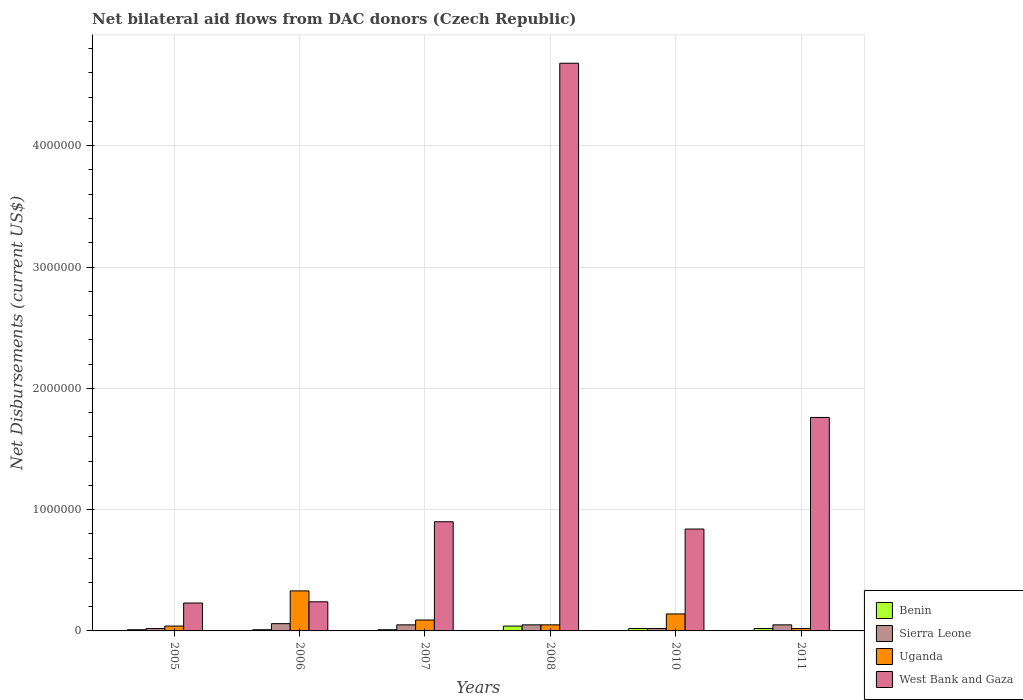How many groups of bars are there?
Keep it short and to the point. 6. Are the number of bars per tick equal to the number of legend labels?
Offer a very short reply. Yes. How many bars are there on the 4th tick from the left?
Offer a terse response. 4. How many bars are there on the 3rd tick from the right?
Your answer should be very brief. 4. What is the label of the 5th group of bars from the left?
Make the answer very short. 2010. In how many cases, is the number of bars for a given year not equal to the number of legend labels?
Ensure brevity in your answer.  0. What is the net bilateral aid flows in Uganda in 2007?
Your answer should be compact. 9.00e+04. Across all years, what is the maximum net bilateral aid flows in Sierra Leone?
Ensure brevity in your answer.  6.00e+04. Across all years, what is the minimum net bilateral aid flows in Uganda?
Your response must be concise. 2.00e+04. In which year was the net bilateral aid flows in Uganda minimum?
Provide a succinct answer. 2011. What is the total net bilateral aid flows in West Bank and Gaza in the graph?
Your answer should be very brief. 8.65e+06. What is the difference between the net bilateral aid flows in Uganda in 2005 and that in 2007?
Your answer should be compact. -5.00e+04. What is the difference between the net bilateral aid flows in West Bank and Gaza in 2007 and the net bilateral aid flows in Benin in 2006?
Provide a short and direct response. 8.90e+05. What is the average net bilateral aid flows in Sierra Leone per year?
Your response must be concise. 4.17e+04. In how many years, is the net bilateral aid flows in Uganda greater than 3800000 US$?
Offer a very short reply. 0. What is the ratio of the net bilateral aid flows in Sierra Leone in 2008 to that in 2011?
Your answer should be compact. 1. Is the net bilateral aid flows in Sierra Leone in 2008 less than that in 2010?
Ensure brevity in your answer.  No. Is the difference between the net bilateral aid flows in Sierra Leone in 2005 and 2010 greater than the difference between the net bilateral aid flows in Uganda in 2005 and 2010?
Offer a very short reply. Yes. What is the difference between the highest and the lowest net bilateral aid flows in West Bank and Gaza?
Provide a succinct answer. 4.45e+06. What does the 4th bar from the left in 2005 represents?
Give a very brief answer. West Bank and Gaza. What does the 3rd bar from the right in 2005 represents?
Make the answer very short. Sierra Leone. How many bars are there?
Keep it short and to the point. 24. Are all the bars in the graph horizontal?
Offer a terse response. No. How many years are there in the graph?
Your answer should be compact. 6. What is the difference between two consecutive major ticks on the Y-axis?
Your response must be concise. 1.00e+06. Are the values on the major ticks of Y-axis written in scientific E-notation?
Your answer should be compact. No. Where does the legend appear in the graph?
Offer a terse response. Bottom right. How many legend labels are there?
Your answer should be very brief. 4. How are the legend labels stacked?
Your response must be concise. Vertical. What is the title of the graph?
Offer a very short reply. Net bilateral aid flows from DAC donors (Czech Republic). What is the label or title of the X-axis?
Provide a short and direct response. Years. What is the label or title of the Y-axis?
Provide a short and direct response. Net Disbursements (current US$). What is the Net Disbursements (current US$) in Sierra Leone in 2005?
Your answer should be very brief. 2.00e+04. What is the Net Disbursements (current US$) in Benin in 2006?
Offer a very short reply. 10000. What is the Net Disbursements (current US$) in Sierra Leone in 2006?
Provide a short and direct response. 6.00e+04. What is the Net Disbursements (current US$) in West Bank and Gaza in 2006?
Your answer should be very brief. 2.40e+05. What is the Net Disbursements (current US$) of Benin in 2007?
Offer a very short reply. 10000. What is the Net Disbursements (current US$) in Sierra Leone in 2007?
Your answer should be very brief. 5.00e+04. What is the Net Disbursements (current US$) of Uganda in 2007?
Ensure brevity in your answer.  9.00e+04. What is the Net Disbursements (current US$) in Sierra Leone in 2008?
Ensure brevity in your answer.  5.00e+04. What is the Net Disbursements (current US$) in West Bank and Gaza in 2008?
Offer a terse response. 4.68e+06. What is the Net Disbursements (current US$) of Sierra Leone in 2010?
Give a very brief answer. 2.00e+04. What is the Net Disbursements (current US$) in Uganda in 2010?
Offer a very short reply. 1.40e+05. What is the Net Disbursements (current US$) in West Bank and Gaza in 2010?
Your response must be concise. 8.40e+05. What is the Net Disbursements (current US$) in West Bank and Gaza in 2011?
Provide a succinct answer. 1.76e+06. Across all years, what is the maximum Net Disbursements (current US$) in West Bank and Gaza?
Your answer should be very brief. 4.68e+06. Across all years, what is the minimum Net Disbursements (current US$) in Benin?
Offer a very short reply. 10000. Across all years, what is the minimum Net Disbursements (current US$) in Sierra Leone?
Provide a succinct answer. 2.00e+04. Across all years, what is the minimum Net Disbursements (current US$) of West Bank and Gaza?
Offer a terse response. 2.30e+05. What is the total Net Disbursements (current US$) in Sierra Leone in the graph?
Offer a terse response. 2.50e+05. What is the total Net Disbursements (current US$) in Uganda in the graph?
Offer a very short reply. 6.70e+05. What is the total Net Disbursements (current US$) of West Bank and Gaza in the graph?
Provide a succinct answer. 8.65e+06. What is the difference between the Net Disbursements (current US$) in West Bank and Gaza in 2005 and that in 2007?
Keep it short and to the point. -6.70e+05. What is the difference between the Net Disbursements (current US$) of Sierra Leone in 2005 and that in 2008?
Provide a short and direct response. -3.00e+04. What is the difference between the Net Disbursements (current US$) of Uganda in 2005 and that in 2008?
Your response must be concise. -10000. What is the difference between the Net Disbursements (current US$) in West Bank and Gaza in 2005 and that in 2008?
Your answer should be very brief. -4.45e+06. What is the difference between the Net Disbursements (current US$) of Sierra Leone in 2005 and that in 2010?
Your answer should be compact. 0. What is the difference between the Net Disbursements (current US$) in Uganda in 2005 and that in 2010?
Your response must be concise. -1.00e+05. What is the difference between the Net Disbursements (current US$) of West Bank and Gaza in 2005 and that in 2010?
Offer a very short reply. -6.10e+05. What is the difference between the Net Disbursements (current US$) of Sierra Leone in 2005 and that in 2011?
Your answer should be compact. -3.00e+04. What is the difference between the Net Disbursements (current US$) of Uganda in 2005 and that in 2011?
Offer a terse response. 2.00e+04. What is the difference between the Net Disbursements (current US$) of West Bank and Gaza in 2005 and that in 2011?
Your answer should be very brief. -1.53e+06. What is the difference between the Net Disbursements (current US$) in Benin in 2006 and that in 2007?
Offer a terse response. 0. What is the difference between the Net Disbursements (current US$) of Sierra Leone in 2006 and that in 2007?
Your answer should be compact. 10000. What is the difference between the Net Disbursements (current US$) in West Bank and Gaza in 2006 and that in 2007?
Your response must be concise. -6.60e+05. What is the difference between the Net Disbursements (current US$) in West Bank and Gaza in 2006 and that in 2008?
Make the answer very short. -4.44e+06. What is the difference between the Net Disbursements (current US$) in Sierra Leone in 2006 and that in 2010?
Make the answer very short. 4.00e+04. What is the difference between the Net Disbursements (current US$) of Uganda in 2006 and that in 2010?
Your answer should be very brief. 1.90e+05. What is the difference between the Net Disbursements (current US$) in West Bank and Gaza in 2006 and that in 2010?
Offer a very short reply. -6.00e+05. What is the difference between the Net Disbursements (current US$) in West Bank and Gaza in 2006 and that in 2011?
Give a very brief answer. -1.52e+06. What is the difference between the Net Disbursements (current US$) in Benin in 2007 and that in 2008?
Your answer should be compact. -3.00e+04. What is the difference between the Net Disbursements (current US$) of West Bank and Gaza in 2007 and that in 2008?
Make the answer very short. -3.78e+06. What is the difference between the Net Disbursements (current US$) in Benin in 2007 and that in 2010?
Offer a terse response. -10000. What is the difference between the Net Disbursements (current US$) in Sierra Leone in 2007 and that in 2011?
Ensure brevity in your answer.  0. What is the difference between the Net Disbursements (current US$) of Uganda in 2007 and that in 2011?
Provide a succinct answer. 7.00e+04. What is the difference between the Net Disbursements (current US$) in West Bank and Gaza in 2007 and that in 2011?
Your response must be concise. -8.60e+05. What is the difference between the Net Disbursements (current US$) in Sierra Leone in 2008 and that in 2010?
Offer a terse response. 3.00e+04. What is the difference between the Net Disbursements (current US$) of Uganda in 2008 and that in 2010?
Offer a very short reply. -9.00e+04. What is the difference between the Net Disbursements (current US$) of West Bank and Gaza in 2008 and that in 2010?
Provide a succinct answer. 3.84e+06. What is the difference between the Net Disbursements (current US$) of Uganda in 2008 and that in 2011?
Provide a short and direct response. 3.00e+04. What is the difference between the Net Disbursements (current US$) of West Bank and Gaza in 2008 and that in 2011?
Your answer should be very brief. 2.92e+06. What is the difference between the Net Disbursements (current US$) of Sierra Leone in 2010 and that in 2011?
Offer a terse response. -3.00e+04. What is the difference between the Net Disbursements (current US$) of Uganda in 2010 and that in 2011?
Ensure brevity in your answer.  1.20e+05. What is the difference between the Net Disbursements (current US$) of West Bank and Gaza in 2010 and that in 2011?
Keep it short and to the point. -9.20e+05. What is the difference between the Net Disbursements (current US$) of Benin in 2005 and the Net Disbursements (current US$) of Uganda in 2006?
Keep it short and to the point. -3.20e+05. What is the difference between the Net Disbursements (current US$) of Sierra Leone in 2005 and the Net Disbursements (current US$) of Uganda in 2006?
Provide a short and direct response. -3.10e+05. What is the difference between the Net Disbursements (current US$) in Sierra Leone in 2005 and the Net Disbursements (current US$) in West Bank and Gaza in 2006?
Your answer should be very brief. -2.20e+05. What is the difference between the Net Disbursements (current US$) in Uganda in 2005 and the Net Disbursements (current US$) in West Bank and Gaza in 2006?
Keep it short and to the point. -2.00e+05. What is the difference between the Net Disbursements (current US$) of Benin in 2005 and the Net Disbursements (current US$) of Sierra Leone in 2007?
Keep it short and to the point. -4.00e+04. What is the difference between the Net Disbursements (current US$) of Benin in 2005 and the Net Disbursements (current US$) of West Bank and Gaza in 2007?
Provide a succinct answer. -8.90e+05. What is the difference between the Net Disbursements (current US$) in Sierra Leone in 2005 and the Net Disbursements (current US$) in Uganda in 2007?
Ensure brevity in your answer.  -7.00e+04. What is the difference between the Net Disbursements (current US$) of Sierra Leone in 2005 and the Net Disbursements (current US$) of West Bank and Gaza in 2007?
Your answer should be compact. -8.80e+05. What is the difference between the Net Disbursements (current US$) in Uganda in 2005 and the Net Disbursements (current US$) in West Bank and Gaza in 2007?
Provide a short and direct response. -8.60e+05. What is the difference between the Net Disbursements (current US$) of Benin in 2005 and the Net Disbursements (current US$) of Sierra Leone in 2008?
Offer a terse response. -4.00e+04. What is the difference between the Net Disbursements (current US$) in Benin in 2005 and the Net Disbursements (current US$) in West Bank and Gaza in 2008?
Your response must be concise. -4.67e+06. What is the difference between the Net Disbursements (current US$) in Sierra Leone in 2005 and the Net Disbursements (current US$) in Uganda in 2008?
Provide a succinct answer. -3.00e+04. What is the difference between the Net Disbursements (current US$) in Sierra Leone in 2005 and the Net Disbursements (current US$) in West Bank and Gaza in 2008?
Provide a succinct answer. -4.66e+06. What is the difference between the Net Disbursements (current US$) in Uganda in 2005 and the Net Disbursements (current US$) in West Bank and Gaza in 2008?
Your answer should be very brief. -4.64e+06. What is the difference between the Net Disbursements (current US$) in Benin in 2005 and the Net Disbursements (current US$) in West Bank and Gaza in 2010?
Keep it short and to the point. -8.30e+05. What is the difference between the Net Disbursements (current US$) of Sierra Leone in 2005 and the Net Disbursements (current US$) of West Bank and Gaza in 2010?
Offer a terse response. -8.20e+05. What is the difference between the Net Disbursements (current US$) of Uganda in 2005 and the Net Disbursements (current US$) of West Bank and Gaza in 2010?
Provide a short and direct response. -8.00e+05. What is the difference between the Net Disbursements (current US$) in Benin in 2005 and the Net Disbursements (current US$) in West Bank and Gaza in 2011?
Your answer should be compact. -1.75e+06. What is the difference between the Net Disbursements (current US$) of Sierra Leone in 2005 and the Net Disbursements (current US$) of West Bank and Gaza in 2011?
Offer a terse response. -1.74e+06. What is the difference between the Net Disbursements (current US$) of Uganda in 2005 and the Net Disbursements (current US$) of West Bank and Gaza in 2011?
Provide a succinct answer. -1.72e+06. What is the difference between the Net Disbursements (current US$) of Benin in 2006 and the Net Disbursements (current US$) of Uganda in 2007?
Keep it short and to the point. -8.00e+04. What is the difference between the Net Disbursements (current US$) of Benin in 2006 and the Net Disbursements (current US$) of West Bank and Gaza in 2007?
Keep it short and to the point. -8.90e+05. What is the difference between the Net Disbursements (current US$) in Sierra Leone in 2006 and the Net Disbursements (current US$) in West Bank and Gaza in 2007?
Offer a terse response. -8.40e+05. What is the difference between the Net Disbursements (current US$) in Uganda in 2006 and the Net Disbursements (current US$) in West Bank and Gaza in 2007?
Make the answer very short. -5.70e+05. What is the difference between the Net Disbursements (current US$) in Benin in 2006 and the Net Disbursements (current US$) in Sierra Leone in 2008?
Ensure brevity in your answer.  -4.00e+04. What is the difference between the Net Disbursements (current US$) of Benin in 2006 and the Net Disbursements (current US$) of West Bank and Gaza in 2008?
Offer a very short reply. -4.67e+06. What is the difference between the Net Disbursements (current US$) of Sierra Leone in 2006 and the Net Disbursements (current US$) of West Bank and Gaza in 2008?
Provide a short and direct response. -4.62e+06. What is the difference between the Net Disbursements (current US$) in Uganda in 2006 and the Net Disbursements (current US$) in West Bank and Gaza in 2008?
Make the answer very short. -4.35e+06. What is the difference between the Net Disbursements (current US$) of Benin in 2006 and the Net Disbursements (current US$) of Sierra Leone in 2010?
Make the answer very short. -10000. What is the difference between the Net Disbursements (current US$) of Benin in 2006 and the Net Disbursements (current US$) of Uganda in 2010?
Your response must be concise. -1.30e+05. What is the difference between the Net Disbursements (current US$) in Benin in 2006 and the Net Disbursements (current US$) in West Bank and Gaza in 2010?
Your response must be concise. -8.30e+05. What is the difference between the Net Disbursements (current US$) of Sierra Leone in 2006 and the Net Disbursements (current US$) of West Bank and Gaza in 2010?
Provide a short and direct response. -7.80e+05. What is the difference between the Net Disbursements (current US$) in Uganda in 2006 and the Net Disbursements (current US$) in West Bank and Gaza in 2010?
Give a very brief answer. -5.10e+05. What is the difference between the Net Disbursements (current US$) in Benin in 2006 and the Net Disbursements (current US$) in Uganda in 2011?
Give a very brief answer. -10000. What is the difference between the Net Disbursements (current US$) in Benin in 2006 and the Net Disbursements (current US$) in West Bank and Gaza in 2011?
Keep it short and to the point. -1.75e+06. What is the difference between the Net Disbursements (current US$) in Sierra Leone in 2006 and the Net Disbursements (current US$) in West Bank and Gaza in 2011?
Ensure brevity in your answer.  -1.70e+06. What is the difference between the Net Disbursements (current US$) in Uganda in 2006 and the Net Disbursements (current US$) in West Bank and Gaza in 2011?
Offer a very short reply. -1.43e+06. What is the difference between the Net Disbursements (current US$) of Benin in 2007 and the Net Disbursements (current US$) of Sierra Leone in 2008?
Your response must be concise. -4.00e+04. What is the difference between the Net Disbursements (current US$) of Benin in 2007 and the Net Disbursements (current US$) of Uganda in 2008?
Ensure brevity in your answer.  -4.00e+04. What is the difference between the Net Disbursements (current US$) in Benin in 2007 and the Net Disbursements (current US$) in West Bank and Gaza in 2008?
Offer a very short reply. -4.67e+06. What is the difference between the Net Disbursements (current US$) in Sierra Leone in 2007 and the Net Disbursements (current US$) in Uganda in 2008?
Give a very brief answer. 0. What is the difference between the Net Disbursements (current US$) of Sierra Leone in 2007 and the Net Disbursements (current US$) of West Bank and Gaza in 2008?
Provide a succinct answer. -4.63e+06. What is the difference between the Net Disbursements (current US$) of Uganda in 2007 and the Net Disbursements (current US$) of West Bank and Gaza in 2008?
Your answer should be very brief. -4.59e+06. What is the difference between the Net Disbursements (current US$) in Benin in 2007 and the Net Disbursements (current US$) in West Bank and Gaza in 2010?
Give a very brief answer. -8.30e+05. What is the difference between the Net Disbursements (current US$) of Sierra Leone in 2007 and the Net Disbursements (current US$) of Uganda in 2010?
Provide a succinct answer. -9.00e+04. What is the difference between the Net Disbursements (current US$) in Sierra Leone in 2007 and the Net Disbursements (current US$) in West Bank and Gaza in 2010?
Give a very brief answer. -7.90e+05. What is the difference between the Net Disbursements (current US$) in Uganda in 2007 and the Net Disbursements (current US$) in West Bank and Gaza in 2010?
Provide a short and direct response. -7.50e+05. What is the difference between the Net Disbursements (current US$) in Benin in 2007 and the Net Disbursements (current US$) in Sierra Leone in 2011?
Give a very brief answer. -4.00e+04. What is the difference between the Net Disbursements (current US$) in Benin in 2007 and the Net Disbursements (current US$) in West Bank and Gaza in 2011?
Your response must be concise. -1.75e+06. What is the difference between the Net Disbursements (current US$) in Sierra Leone in 2007 and the Net Disbursements (current US$) in Uganda in 2011?
Make the answer very short. 3.00e+04. What is the difference between the Net Disbursements (current US$) of Sierra Leone in 2007 and the Net Disbursements (current US$) of West Bank and Gaza in 2011?
Keep it short and to the point. -1.71e+06. What is the difference between the Net Disbursements (current US$) of Uganda in 2007 and the Net Disbursements (current US$) of West Bank and Gaza in 2011?
Provide a succinct answer. -1.67e+06. What is the difference between the Net Disbursements (current US$) in Benin in 2008 and the Net Disbursements (current US$) in Sierra Leone in 2010?
Your answer should be compact. 2.00e+04. What is the difference between the Net Disbursements (current US$) in Benin in 2008 and the Net Disbursements (current US$) in Uganda in 2010?
Your answer should be compact. -1.00e+05. What is the difference between the Net Disbursements (current US$) in Benin in 2008 and the Net Disbursements (current US$) in West Bank and Gaza in 2010?
Provide a succinct answer. -8.00e+05. What is the difference between the Net Disbursements (current US$) of Sierra Leone in 2008 and the Net Disbursements (current US$) of Uganda in 2010?
Ensure brevity in your answer.  -9.00e+04. What is the difference between the Net Disbursements (current US$) of Sierra Leone in 2008 and the Net Disbursements (current US$) of West Bank and Gaza in 2010?
Offer a very short reply. -7.90e+05. What is the difference between the Net Disbursements (current US$) in Uganda in 2008 and the Net Disbursements (current US$) in West Bank and Gaza in 2010?
Your answer should be compact. -7.90e+05. What is the difference between the Net Disbursements (current US$) in Benin in 2008 and the Net Disbursements (current US$) in Uganda in 2011?
Give a very brief answer. 2.00e+04. What is the difference between the Net Disbursements (current US$) of Benin in 2008 and the Net Disbursements (current US$) of West Bank and Gaza in 2011?
Your answer should be compact. -1.72e+06. What is the difference between the Net Disbursements (current US$) in Sierra Leone in 2008 and the Net Disbursements (current US$) in West Bank and Gaza in 2011?
Ensure brevity in your answer.  -1.71e+06. What is the difference between the Net Disbursements (current US$) in Uganda in 2008 and the Net Disbursements (current US$) in West Bank and Gaza in 2011?
Ensure brevity in your answer.  -1.71e+06. What is the difference between the Net Disbursements (current US$) of Benin in 2010 and the Net Disbursements (current US$) of West Bank and Gaza in 2011?
Ensure brevity in your answer.  -1.74e+06. What is the difference between the Net Disbursements (current US$) in Sierra Leone in 2010 and the Net Disbursements (current US$) in Uganda in 2011?
Offer a terse response. 0. What is the difference between the Net Disbursements (current US$) in Sierra Leone in 2010 and the Net Disbursements (current US$) in West Bank and Gaza in 2011?
Ensure brevity in your answer.  -1.74e+06. What is the difference between the Net Disbursements (current US$) of Uganda in 2010 and the Net Disbursements (current US$) of West Bank and Gaza in 2011?
Offer a very short reply. -1.62e+06. What is the average Net Disbursements (current US$) of Benin per year?
Offer a terse response. 1.83e+04. What is the average Net Disbursements (current US$) in Sierra Leone per year?
Offer a very short reply. 4.17e+04. What is the average Net Disbursements (current US$) in Uganda per year?
Your response must be concise. 1.12e+05. What is the average Net Disbursements (current US$) in West Bank and Gaza per year?
Provide a succinct answer. 1.44e+06. In the year 2005, what is the difference between the Net Disbursements (current US$) in Benin and Net Disbursements (current US$) in Uganda?
Give a very brief answer. -3.00e+04. In the year 2006, what is the difference between the Net Disbursements (current US$) of Benin and Net Disbursements (current US$) of Sierra Leone?
Provide a short and direct response. -5.00e+04. In the year 2006, what is the difference between the Net Disbursements (current US$) in Benin and Net Disbursements (current US$) in Uganda?
Provide a succinct answer. -3.20e+05. In the year 2006, what is the difference between the Net Disbursements (current US$) of Benin and Net Disbursements (current US$) of West Bank and Gaza?
Your answer should be very brief. -2.30e+05. In the year 2006, what is the difference between the Net Disbursements (current US$) of Sierra Leone and Net Disbursements (current US$) of Uganda?
Your response must be concise. -2.70e+05. In the year 2006, what is the difference between the Net Disbursements (current US$) in Uganda and Net Disbursements (current US$) in West Bank and Gaza?
Offer a very short reply. 9.00e+04. In the year 2007, what is the difference between the Net Disbursements (current US$) of Benin and Net Disbursements (current US$) of Sierra Leone?
Provide a short and direct response. -4.00e+04. In the year 2007, what is the difference between the Net Disbursements (current US$) of Benin and Net Disbursements (current US$) of Uganda?
Keep it short and to the point. -8.00e+04. In the year 2007, what is the difference between the Net Disbursements (current US$) of Benin and Net Disbursements (current US$) of West Bank and Gaza?
Provide a short and direct response. -8.90e+05. In the year 2007, what is the difference between the Net Disbursements (current US$) of Sierra Leone and Net Disbursements (current US$) of West Bank and Gaza?
Offer a very short reply. -8.50e+05. In the year 2007, what is the difference between the Net Disbursements (current US$) of Uganda and Net Disbursements (current US$) of West Bank and Gaza?
Your response must be concise. -8.10e+05. In the year 2008, what is the difference between the Net Disbursements (current US$) in Benin and Net Disbursements (current US$) in Uganda?
Your answer should be compact. -10000. In the year 2008, what is the difference between the Net Disbursements (current US$) of Benin and Net Disbursements (current US$) of West Bank and Gaza?
Ensure brevity in your answer.  -4.64e+06. In the year 2008, what is the difference between the Net Disbursements (current US$) of Sierra Leone and Net Disbursements (current US$) of West Bank and Gaza?
Provide a succinct answer. -4.63e+06. In the year 2008, what is the difference between the Net Disbursements (current US$) in Uganda and Net Disbursements (current US$) in West Bank and Gaza?
Ensure brevity in your answer.  -4.63e+06. In the year 2010, what is the difference between the Net Disbursements (current US$) of Benin and Net Disbursements (current US$) of West Bank and Gaza?
Offer a very short reply. -8.20e+05. In the year 2010, what is the difference between the Net Disbursements (current US$) in Sierra Leone and Net Disbursements (current US$) in West Bank and Gaza?
Your answer should be very brief. -8.20e+05. In the year 2010, what is the difference between the Net Disbursements (current US$) of Uganda and Net Disbursements (current US$) of West Bank and Gaza?
Offer a terse response. -7.00e+05. In the year 2011, what is the difference between the Net Disbursements (current US$) in Benin and Net Disbursements (current US$) in West Bank and Gaza?
Your answer should be very brief. -1.74e+06. In the year 2011, what is the difference between the Net Disbursements (current US$) in Sierra Leone and Net Disbursements (current US$) in West Bank and Gaza?
Your answer should be very brief. -1.71e+06. In the year 2011, what is the difference between the Net Disbursements (current US$) of Uganda and Net Disbursements (current US$) of West Bank and Gaza?
Your answer should be very brief. -1.74e+06. What is the ratio of the Net Disbursements (current US$) of Benin in 2005 to that in 2006?
Your response must be concise. 1. What is the ratio of the Net Disbursements (current US$) of Sierra Leone in 2005 to that in 2006?
Offer a very short reply. 0.33. What is the ratio of the Net Disbursements (current US$) of Uganda in 2005 to that in 2006?
Give a very brief answer. 0.12. What is the ratio of the Net Disbursements (current US$) of West Bank and Gaza in 2005 to that in 2006?
Your answer should be very brief. 0.96. What is the ratio of the Net Disbursements (current US$) in Benin in 2005 to that in 2007?
Provide a short and direct response. 1. What is the ratio of the Net Disbursements (current US$) of Uganda in 2005 to that in 2007?
Provide a short and direct response. 0.44. What is the ratio of the Net Disbursements (current US$) in West Bank and Gaza in 2005 to that in 2007?
Ensure brevity in your answer.  0.26. What is the ratio of the Net Disbursements (current US$) of Benin in 2005 to that in 2008?
Offer a very short reply. 0.25. What is the ratio of the Net Disbursements (current US$) of Uganda in 2005 to that in 2008?
Provide a succinct answer. 0.8. What is the ratio of the Net Disbursements (current US$) of West Bank and Gaza in 2005 to that in 2008?
Your answer should be very brief. 0.05. What is the ratio of the Net Disbursements (current US$) in Benin in 2005 to that in 2010?
Offer a terse response. 0.5. What is the ratio of the Net Disbursements (current US$) of Sierra Leone in 2005 to that in 2010?
Your response must be concise. 1. What is the ratio of the Net Disbursements (current US$) in Uganda in 2005 to that in 2010?
Ensure brevity in your answer.  0.29. What is the ratio of the Net Disbursements (current US$) of West Bank and Gaza in 2005 to that in 2010?
Your answer should be very brief. 0.27. What is the ratio of the Net Disbursements (current US$) in Benin in 2005 to that in 2011?
Keep it short and to the point. 0.5. What is the ratio of the Net Disbursements (current US$) in Sierra Leone in 2005 to that in 2011?
Provide a succinct answer. 0.4. What is the ratio of the Net Disbursements (current US$) of West Bank and Gaza in 2005 to that in 2011?
Offer a terse response. 0.13. What is the ratio of the Net Disbursements (current US$) of Benin in 2006 to that in 2007?
Your response must be concise. 1. What is the ratio of the Net Disbursements (current US$) of Sierra Leone in 2006 to that in 2007?
Your answer should be compact. 1.2. What is the ratio of the Net Disbursements (current US$) of Uganda in 2006 to that in 2007?
Your response must be concise. 3.67. What is the ratio of the Net Disbursements (current US$) in West Bank and Gaza in 2006 to that in 2007?
Your answer should be very brief. 0.27. What is the ratio of the Net Disbursements (current US$) in Uganda in 2006 to that in 2008?
Make the answer very short. 6.6. What is the ratio of the Net Disbursements (current US$) of West Bank and Gaza in 2006 to that in 2008?
Your answer should be very brief. 0.05. What is the ratio of the Net Disbursements (current US$) of Sierra Leone in 2006 to that in 2010?
Keep it short and to the point. 3. What is the ratio of the Net Disbursements (current US$) of Uganda in 2006 to that in 2010?
Give a very brief answer. 2.36. What is the ratio of the Net Disbursements (current US$) of West Bank and Gaza in 2006 to that in 2010?
Keep it short and to the point. 0.29. What is the ratio of the Net Disbursements (current US$) of West Bank and Gaza in 2006 to that in 2011?
Offer a terse response. 0.14. What is the ratio of the Net Disbursements (current US$) in Benin in 2007 to that in 2008?
Ensure brevity in your answer.  0.25. What is the ratio of the Net Disbursements (current US$) in West Bank and Gaza in 2007 to that in 2008?
Your answer should be very brief. 0.19. What is the ratio of the Net Disbursements (current US$) of Benin in 2007 to that in 2010?
Offer a terse response. 0.5. What is the ratio of the Net Disbursements (current US$) of Sierra Leone in 2007 to that in 2010?
Provide a short and direct response. 2.5. What is the ratio of the Net Disbursements (current US$) in Uganda in 2007 to that in 2010?
Give a very brief answer. 0.64. What is the ratio of the Net Disbursements (current US$) of West Bank and Gaza in 2007 to that in 2010?
Ensure brevity in your answer.  1.07. What is the ratio of the Net Disbursements (current US$) in Benin in 2007 to that in 2011?
Ensure brevity in your answer.  0.5. What is the ratio of the Net Disbursements (current US$) of West Bank and Gaza in 2007 to that in 2011?
Ensure brevity in your answer.  0.51. What is the ratio of the Net Disbursements (current US$) of Benin in 2008 to that in 2010?
Make the answer very short. 2. What is the ratio of the Net Disbursements (current US$) of Sierra Leone in 2008 to that in 2010?
Your answer should be very brief. 2.5. What is the ratio of the Net Disbursements (current US$) in Uganda in 2008 to that in 2010?
Give a very brief answer. 0.36. What is the ratio of the Net Disbursements (current US$) in West Bank and Gaza in 2008 to that in 2010?
Make the answer very short. 5.57. What is the ratio of the Net Disbursements (current US$) in Benin in 2008 to that in 2011?
Ensure brevity in your answer.  2. What is the ratio of the Net Disbursements (current US$) in Sierra Leone in 2008 to that in 2011?
Offer a very short reply. 1. What is the ratio of the Net Disbursements (current US$) of West Bank and Gaza in 2008 to that in 2011?
Your answer should be very brief. 2.66. What is the ratio of the Net Disbursements (current US$) of Benin in 2010 to that in 2011?
Your answer should be very brief. 1. What is the ratio of the Net Disbursements (current US$) of Uganda in 2010 to that in 2011?
Make the answer very short. 7. What is the ratio of the Net Disbursements (current US$) of West Bank and Gaza in 2010 to that in 2011?
Keep it short and to the point. 0.48. What is the difference between the highest and the second highest Net Disbursements (current US$) in Sierra Leone?
Your answer should be very brief. 10000. What is the difference between the highest and the second highest Net Disbursements (current US$) of West Bank and Gaza?
Offer a terse response. 2.92e+06. What is the difference between the highest and the lowest Net Disbursements (current US$) in Benin?
Offer a terse response. 3.00e+04. What is the difference between the highest and the lowest Net Disbursements (current US$) of Sierra Leone?
Offer a terse response. 4.00e+04. What is the difference between the highest and the lowest Net Disbursements (current US$) in Uganda?
Offer a terse response. 3.10e+05. What is the difference between the highest and the lowest Net Disbursements (current US$) in West Bank and Gaza?
Offer a terse response. 4.45e+06. 